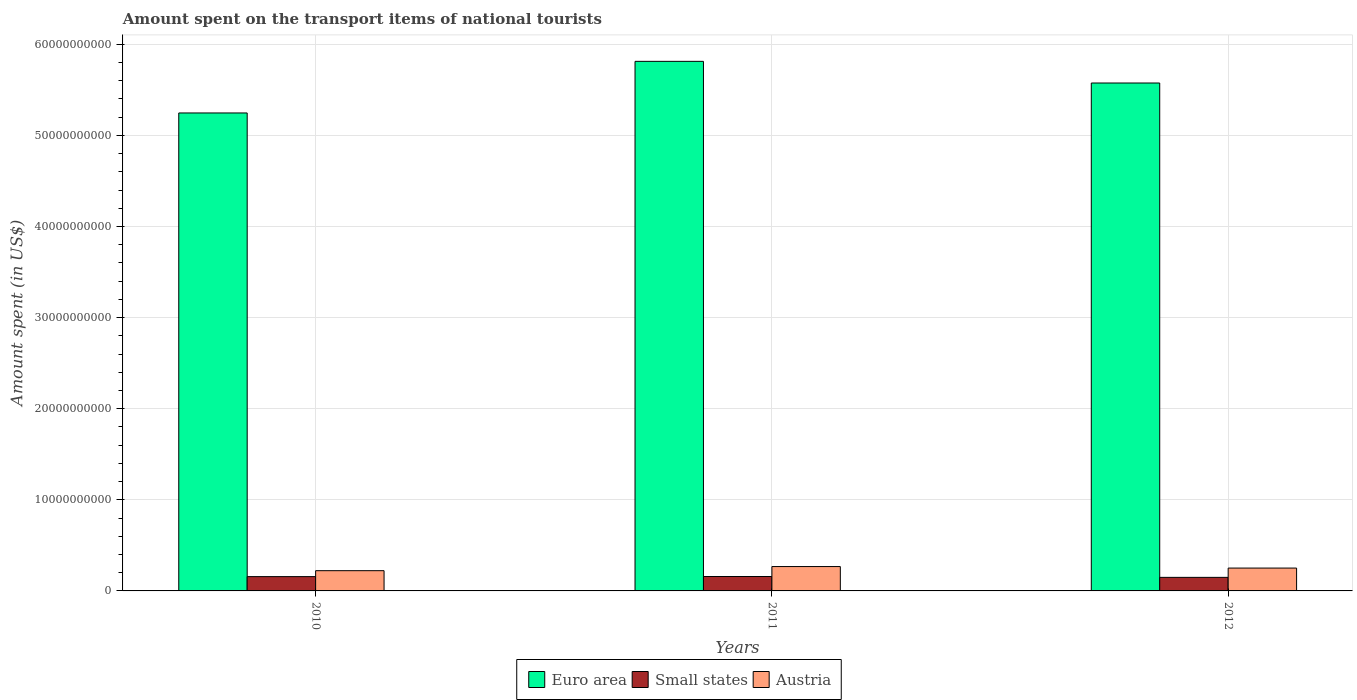Are the number of bars on each tick of the X-axis equal?
Give a very brief answer. Yes. How many bars are there on the 3rd tick from the left?
Your answer should be compact. 3. What is the label of the 1st group of bars from the left?
Ensure brevity in your answer.  2010. In how many cases, is the number of bars for a given year not equal to the number of legend labels?
Your answer should be compact. 0. What is the amount spent on the transport items of national tourists in Euro area in 2011?
Your answer should be compact. 5.81e+1. Across all years, what is the maximum amount spent on the transport items of national tourists in Euro area?
Offer a terse response. 5.81e+1. Across all years, what is the minimum amount spent on the transport items of national tourists in Euro area?
Offer a terse response. 5.25e+1. In which year was the amount spent on the transport items of national tourists in Austria maximum?
Your answer should be very brief. 2011. In which year was the amount spent on the transport items of national tourists in Austria minimum?
Ensure brevity in your answer.  2010. What is the total amount spent on the transport items of national tourists in Small states in the graph?
Make the answer very short. 4.64e+09. What is the difference between the amount spent on the transport items of national tourists in Euro area in 2010 and that in 2012?
Your response must be concise. -3.29e+09. What is the difference between the amount spent on the transport items of national tourists in Small states in 2010 and the amount spent on the transport items of national tourists in Austria in 2012?
Keep it short and to the point. -9.38e+08. What is the average amount spent on the transport items of national tourists in Austria per year?
Your answer should be compact. 2.47e+09. In the year 2011, what is the difference between the amount spent on the transport items of national tourists in Small states and amount spent on the transport items of national tourists in Austria?
Make the answer very short. -1.09e+09. What is the ratio of the amount spent on the transport items of national tourists in Austria in 2011 to that in 2012?
Make the answer very short. 1.07. Is the difference between the amount spent on the transport items of national tourists in Small states in 2011 and 2012 greater than the difference between the amount spent on the transport items of national tourists in Austria in 2011 and 2012?
Your response must be concise. No. What is the difference between the highest and the second highest amount spent on the transport items of national tourists in Austria?
Your response must be concise. 1.67e+08. What is the difference between the highest and the lowest amount spent on the transport items of national tourists in Austria?
Ensure brevity in your answer.  4.53e+08. In how many years, is the amount spent on the transport items of national tourists in Austria greater than the average amount spent on the transport items of national tourists in Austria taken over all years?
Keep it short and to the point. 2. Is the sum of the amount spent on the transport items of national tourists in Small states in 2011 and 2012 greater than the maximum amount spent on the transport items of national tourists in Austria across all years?
Give a very brief answer. Yes. What does the 2nd bar from the left in 2012 represents?
Provide a succinct answer. Small states. What does the 3rd bar from the right in 2012 represents?
Provide a succinct answer. Euro area. Is it the case that in every year, the sum of the amount spent on the transport items of national tourists in Small states and amount spent on the transport items of national tourists in Austria is greater than the amount spent on the transport items of national tourists in Euro area?
Give a very brief answer. No. Are all the bars in the graph horizontal?
Your answer should be compact. No. What is the difference between two consecutive major ticks on the Y-axis?
Your response must be concise. 1.00e+1. Does the graph contain grids?
Make the answer very short. Yes. Where does the legend appear in the graph?
Offer a terse response. Bottom center. How many legend labels are there?
Your answer should be compact. 3. How are the legend labels stacked?
Provide a short and direct response. Horizontal. What is the title of the graph?
Offer a terse response. Amount spent on the transport items of national tourists. What is the label or title of the Y-axis?
Your answer should be very brief. Amount spent (in US$). What is the Amount spent (in US$) of Euro area in 2010?
Give a very brief answer. 5.25e+1. What is the Amount spent (in US$) of Small states in 2010?
Keep it short and to the point. 1.57e+09. What is the Amount spent (in US$) in Austria in 2010?
Give a very brief answer. 2.22e+09. What is the Amount spent (in US$) of Euro area in 2011?
Ensure brevity in your answer.  5.81e+1. What is the Amount spent (in US$) in Small states in 2011?
Your answer should be compact. 1.58e+09. What is the Amount spent (in US$) in Austria in 2011?
Your response must be concise. 2.68e+09. What is the Amount spent (in US$) in Euro area in 2012?
Offer a very short reply. 5.57e+1. What is the Amount spent (in US$) of Small states in 2012?
Keep it short and to the point. 1.49e+09. What is the Amount spent (in US$) in Austria in 2012?
Provide a succinct answer. 2.51e+09. Across all years, what is the maximum Amount spent (in US$) of Euro area?
Your answer should be compact. 5.81e+1. Across all years, what is the maximum Amount spent (in US$) of Small states?
Give a very brief answer. 1.58e+09. Across all years, what is the maximum Amount spent (in US$) in Austria?
Keep it short and to the point. 2.68e+09. Across all years, what is the minimum Amount spent (in US$) in Euro area?
Ensure brevity in your answer.  5.25e+1. Across all years, what is the minimum Amount spent (in US$) of Small states?
Keep it short and to the point. 1.49e+09. Across all years, what is the minimum Amount spent (in US$) of Austria?
Keep it short and to the point. 2.22e+09. What is the total Amount spent (in US$) in Euro area in the graph?
Offer a terse response. 1.66e+11. What is the total Amount spent (in US$) in Small states in the graph?
Provide a short and direct response. 4.64e+09. What is the total Amount spent (in US$) of Austria in the graph?
Keep it short and to the point. 7.40e+09. What is the difference between the Amount spent (in US$) in Euro area in 2010 and that in 2011?
Provide a succinct answer. -5.66e+09. What is the difference between the Amount spent (in US$) in Small states in 2010 and that in 2011?
Ensure brevity in your answer.  -1.12e+07. What is the difference between the Amount spent (in US$) of Austria in 2010 and that in 2011?
Ensure brevity in your answer.  -4.53e+08. What is the difference between the Amount spent (in US$) in Euro area in 2010 and that in 2012?
Provide a short and direct response. -3.29e+09. What is the difference between the Amount spent (in US$) of Small states in 2010 and that in 2012?
Offer a very short reply. 8.29e+07. What is the difference between the Amount spent (in US$) of Austria in 2010 and that in 2012?
Your response must be concise. -2.86e+08. What is the difference between the Amount spent (in US$) in Euro area in 2011 and that in 2012?
Offer a very short reply. 2.38e+09. What is the difference between the Amount spent (in US$) of Small states in 2011 and that in 2012?
Ensure brevity in your answer.  9.41e+07. What is the difference between the Amount spent (in US$) in Austria in 2011 and that in 2012?
Provide a succinct answer. 1.67e+08. What is the difference between the Amount spent (in US$) of Euro area in 2010 and the Amount spent (in US$) of Small states in 2011?
Provide a succinct answer. 5.09e+1. What is the difference between the Amount spent (in US$) of Euro area in 2010 and the Amount spent (in US$) of Austria in 2011?
Provide a succinct answer. 4.98e+1. What is the difference between the Amount spent (in US$) in Small states in 2010 and the Amount spent (in US$) in Austria in 2011?
Your answer should be compact. -1.10e+09. What is the difference between the Amount spent (in US$) of Euro area in 2010 and the Amount spent (in US$) of Small states in 2012?
Your answer should be very brief. 5.10e+1. What is the difference between the Amount spent (in US$) of Euro area in 2010 and the Amount spent (in US$) of Austria in 2012?
Your response must be concise. 4.99e+1. What is the difference between the Amount spent (in US$) in Small states in 2010 and the Amount spent (in US$) in Austria in 2012?
Provide a succinct answer. -9.38e+08. What is the difference between the Amount spent (in US$) in Euro area in 2011 and the Amount spent (in US$) in Small states in 2012?
Make the answer very short. 5.66e+1. What is the difference between the Amount spent (in US$) in Euro area in 2011 and the Amount spent (in US$) in Austria in 2012?
Your response must be concise. 5.56e+1. What is the difference between the Amount spent (in US$) of Small states in 2011 and the Amount spent (in US$) of Austria in 2012?
Offer a very short reply. -9.27e+08. What is the average Amount spent (in US$) of Euro area per year?
Your answer should be compact. 5.54e+1. What is the average Amount spent (in US$) of Small states per year?
Provide a short and direct response. 1.55e+09. What is the average Amount spent (in US$) in Austria per year?
Your response must be concise. 2.47e+09. In the year 2010, what is the difference between the Amount spent (in US$) in Euro area and Amount spent (in US$) in Small states?
Your answer should be very brief. 5.09e+1. In the year 2010, what is the difference between the Amount spent (in US$) of Euro area and Amount spent (in US$) of Austria?
Offer a terse response. 5.02e+1. In the year 2010, what is the difference between the Amount spent (in US$) of Small states and Amount spent (in US$) of Austria?
Your answer should be compact. -6.52e+08. In the year 2011, what is the difference between the Amount spent (in US$) of Euro area and Amount spent (in US$) of Small states?
Provide a succinct answer. 5.65e+1. In the year 2011, what is the difference between the Amount spent (in US$) in Euro area and Amount spent (in US$) in Austria?
Make the answer very short. 5.54e+1. In the year 2011, what is the difference between the Amount spent (in US$) of Small states and Amount spent (in US$) of Austria?
Provide a succinct answer. -1.09e+09. In the year 2012, what is the difference between the Amount spent (in US$) in Euro area and Amount spent (in US$) in Small states?
Provide a succinct answer. 5.43e+1. In the year 2012, what is the difference between the Amount spent (in US$) in Euro area and Amount spent (in US$) in Austria?
Provide a short and direct response. 5.32e+1. In the year 2012, what is the difference between the Amount spent (in US$) in Small states and Amount spent (in US$) in Austria?
Keep it short and to the point. -1.02e+09. What is the ratio of the Amount spent (in US$) in Euro area in 2010 to that in 2011?
Make the answer very short. 0.9. What is the ratio of the Amount spent (in US$) in Austria in 2010 to that in 2011?
Give a very brief answer. 0.83. What is the ratio of the Amount spent (in US$) in Euro area in 2010 to that in 2012?
Provide a short and direct response. 0.94. What is the ratio of the Amount spent (in US$) of Small states in 2010 to that in 2012?
Give a very brief answer. 1.06. What is the ratio of the Amount spent (in US$) of Austria in 2010 to that in 2012?
Offer a very short reply. 0.89. What is the ratio of the Amount spent (in US$) of Euro area in 2011 to that in 2012?
Offer a very short reply. 1.04. What is the ratio of the Amount spent (in US$) of Small states in 2011 to that in 2012?
Your answer should be very brief. 1.06. What is the ratio of the Amount spent (in US$) in Austria in 2011 to that in 2012?
Offer a very short reply. 1.07. What is the difference between the highest and the second highest Amount spent (in US$) in Euro area?
Provide a short and direct response. 2.38e+09. What is the difference between the highest and the second highest Amount spent (in US$) of Small states?
Your answer should be compact. 1.12e+07. What is the difference between the highest and the second highest Amount spent (in US$) in Austria?
Offer a very short reply. 1.67e+08. What is the difference between the highest and the lowest Amount spent (in US$) of Euro area?
Give a very brief answer. 5.66e+09. What is the difference between the highest and the lowest Amount spent (in US$) of Small states?
Ensure brevity in your answer.  9.41e+07. What is the difference between the highest and the lowest Amount spent (in US$) in Austria?
Keep it short and to the point. 4.53e+08. 